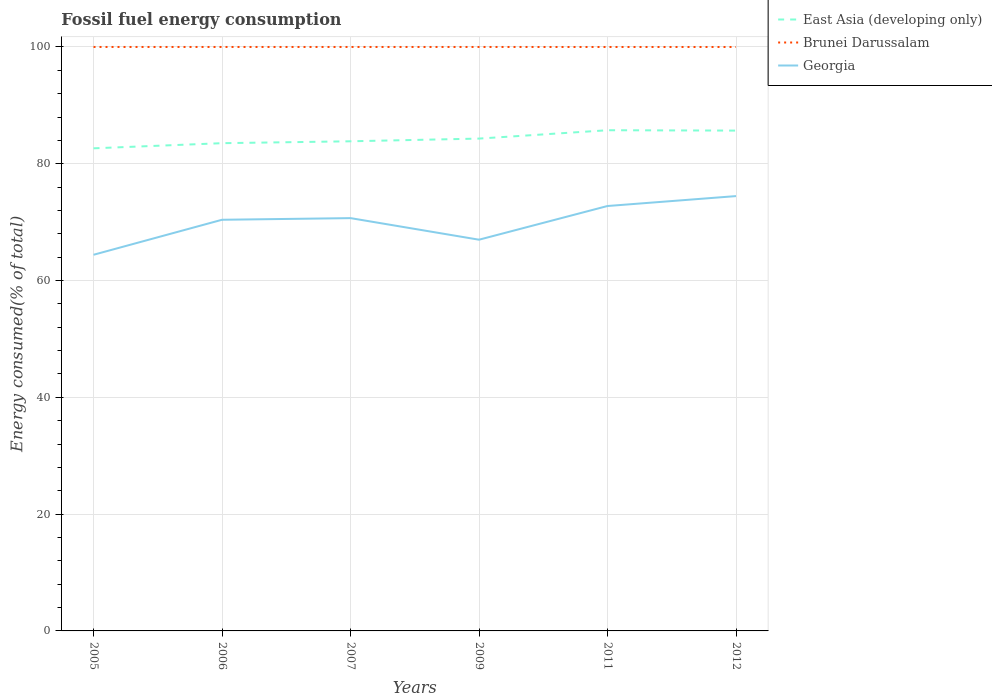Does the line corresponding to East Asia (developing only) intersect with the line corresponding to Brunei Darussalam?
Make the answer very short. No. Across all years, what is the maximum percentage of energy consumed in Georgia?
Offer a very short reply. 64.41. In which year was the percentage of energy consumed in Georgia maximum?
Make the answer very short. 2005. What is the total percentage of energy consumed in Georgia in the graph?
Your answer should be compact. -1.7. What is the difference between the highest and the second highest percentage of energy consumed in Georgia?
Provide a short and direct response. 10.05. What is the difference between the highest and the lowest percentage of energy consumed in Georgia?
Make the answer very short. 4. Are the values on the major ticks of Y-axis written in scientific E-notation?
Offer a terse response. No. Does the graph contain any zero values?
Provide a succinct answer. No. Does the graph contain grids?
Your answer should be compact. Yes. What is the title of the graph?
Give a very brief answer. Fossil fuel energy consumption. What is the label or title of the X-axis?
Your response must be concise. Years. What is the label or title of the Y-axis?
Your response must be concise. Energy consumed(% of total). What is the Energy consumed(% of total) in East Asia (developing only) in 2005?
Offer a terse response. 82.64. What is the Energy consumed(% of total) of Brunei Darussalam in 2005?
Your response must be concise. 100. What is the Energy consumed(% of total) in Georgia in 2005?
Keep it short and to the point. 64.41. What is the Energy consumed(% of total) of East Asia (developing only) in 2006?
Keep it short and to the point. 83.52. What is the Energy consumed(% of total) of Brunei Darussalam in 2006?
Provide a succinct answer. 100. What is the Energy consumed(% of total) in Georgia in 2006?
Your answer should be compact. 70.41. What is the Energy consumed(% of total) of East Asia (developing only) in 2007?
Keep it short and to the point. 83.85. What is the Energy consumed(% of total) of Georgia in 2007?
Provide a succinct answer. 70.69. What is the Energy consumed(% of total) in East Asia (developing only) in 2009?
Offer a very short reply. 84.31. What is the Energy consumed(% of total) in Brunei Darussalam in 2009?
Your response must be concise. 100. What is the Energy consumed(% of total) of Georgia in 2009?
Offer a very short reply. 66.99. What is the Energy consumed(% of total) of East Asia (developing only) in 2011?
Provide a succinct answer. 85.74. What is the Energy consumed(% of total) in Brunei Darussalam in 2011?
Provide a succinct answer. 100. What is the Energy consumed(% of total) of Georgia in 2011?
Ensure brevity in your answer.  72.77. What is the Energy consumed(% of total) of East Asia (developing only) in 2012?
Provide a short and direct response. 85.68. What is the Energy consumed(% of total) in Brunei Darussalam in 2012?
Offer a very short reply. 100. What is the Energy consumed(% of total) of Georgia in 2012?
Ensure brevity in your answer.  74.46. Across all years, what is the maximum Energy consumed(% of total) in East Asia (developing only)?
Your answer should be very brief. 85.74. Across all years, what is the maximum Energy consumed(% of total) in Brunei Darussalam?
Offer a very short reply. 100. Across all years, what is the maximum Energy consumed(% of total) of Georgia?
Provide a short and direct response. 74.46. Across all years, what is the minimum Energy consumed(% of total) of East Asia (developing only)?
Provide a succinct answer. 82.64. Across all years, what is the minimum Energy consumed(% of total) in Brunei Darussalam?
Your answer should be compact. 100. Across all years, what is the minimum Energy consumed(% of total) in Georgia?
Offer a terse response. 64.41. What is the total Energy consumed(% of total) of East Asia (developing only) in the graph?
Keep it short and to the point. 505.75. What is the total Energy consumed(% of total) of Brunei Darussalam in the graph?
Provide a succinct answer. 599.99. What is the total Energy consumed(% of total) of Georgia in the graph?
Provide a succinct answer. 419.73. What is the difference between the Energy consumed(% of total) of East Asia (developing only) in 2005 and that in 2006?
Give a very brief answer. -0.88. What is the difference between the Energy consumed(% of total) in Brunei Darussalam in 2005 and that in 2006?
Your answer should be very brief. 0. What is the difference between the Energy consumed(% of total) in Georgia in 2005 and that in 2006?
Offer a very short reply. -6. What is the difference between the Energy consumed(% of total) of East Asia (developing only) in 2005 and that in 2007?
Give a very brief answer. -1.2. What is the difference between the Energy consumed(% of total) in Brunei Darussalam in 2005 and that in 2007?
Ensure brevity in your answer.  0. What is the difference between the Energy consumed(% of total) of Georgia in 2005 and that in 2007?
Your answer should be very brief. -6.28. What is the difference between the Energy consumed(% of total) in East Asia (developing only) in 2005 and that in 2009?
Give a very brief answer. -1.67. What is the difference between the Energy consumed(% of total) of Georgia in 2005 and that in 2009?
Give a very brief answer. -2.58. What is the difference between the Energy consumed(% of total) in East Asia (developing only) in 2005 and that in 2011?
Provide a succinct answer. -3.1. What is the difference between the Energy consumed(% of total) of Brunei Darussalam in 2005 and that in 2011?
Keep it short and to the point. 0. What is the difference between the Energy consumed(% of total) of Georgia in 2005 and that in 2011?
Offer a terse response. -8.35. What is the difference between the Energy consumed(% of total) in East Asia (developing only) in 2005 and that in 2012?
Your answer should be very brief. -3.04. What is the difference between the Energy consumed(% of total) of Brunei Darussalam in 2005 and that in 2012?
Your answer should be compact. 0. What is the difference between the Energy consumed(% of total) in Georgia in 2005 and that in 2012?
Your answer should be very brief. -10.05. What is the difference between the Energy consumed(% of total) in East Asia (developing only) in 2006 and that in 2007?
Offer a very short reply. -0.32. What is the difference between the Energy consumed(% of total) of Georgia in 2006 and that in 2007?
Offer a very short reply. -0.28. What is the difference between the Energy consumed(% of total) in East Asia (developing only) in 2006 and that in 2009?
Offer a very short reply. -0.79. What is the difference between the Energy consumed(% of total) in Brunei Darussalam in 2006 and that in 2009?
Make the answer very short. 0. What is the difference between the Energy consumed(% of total) in Georgia in 2006 and that in 2009?
Offer a very short reply. 3.42. What is the difference between the Energy consumed(% of total) of East Asia (developing only) in 2006 and that in 2011?
Ensure brevity in your answer.  -2.22. What is the difference between the Energy consumed(% of total) of Brunei Darussalam in 2006 and that in 2011?
Give a very brief answer. 0. What is the difference between the Energy consumed(% of total) of Georgia in 2006 and that in 2011?
Keep it short and to the point. -2.36. What is the difference between the Energy consumed(% of total) in East Asia (developing only) in 2006 and that in 2012?
Offer a terse response. -2.16. What is the difference between the Energy consumed(% of total) of Brunei Darussalam in 2006 and that in 2012?
Provide a succinct answer. 0. What is the difference between the Energy consumed(% of total) in Georgia in 2006 and that in 2012?
Keep it short and to the point. -4.05. What is the difference between the Energy consumed(% of total) in East Asia (developing only) in 2007 and that in 2009?
Offer a very short reply. -0.46. What is the difference between the Energy consumed(% of total) of Brunei Darussalam in 2007 and that in 2009?
Your response must be concise. 0. What is the difference between the Energy consumed(% of total) in Georgia in 2007 and that in 2009?
Offer a very short reply. 3.7. What is the difference between the Energy consumed(% of total) of East Asia (developing only) in 2007 and that in 2011?
Offer a terse response. -1.89. What is the difference between the Energy consumed(% of total) in Brunei Darussalam in 2007 and that in 2011?
Provide a succinct answer. 0. What is the difference between the Energy consumed(% of total) of Georgia in 2007 and that in 2011?
Your response must be concise. -2.07. What is the difference between the Energy consumed(% of total) of East Asia (developing only) in 2007 and that in 2012?
Give a very brief answer. -1.83. What is the difference between the Energy consumed(% of total) in Brunei Darussalam in 2007 and that in 2012?
Make the answer very short. 0. What is the difference between the Energy consumed(% of total) in Georgia in 2007 and that in 2012?
Offer a terse response. -3.77. What is the difference between the Energy consumed(% of total) in East Asia (developing only) in 2009 and that in 2011?
Offer a very short reply. -1.43. What is the difference between the Energy consumed(% of total) in Brunei Darussalam in 2009 and that in 2011?
Keep it short and to the point. 0. What is the difference between the Energy consumed(% of total) in Georgia in 2009 and that in 2011?
Your answer should be very brief. -5.77. What is the difference between the Energy consumed(% of total) of East Asia (developing only) in 2009 and that in 2012?
Keep it short and to the point. -1.37. What is the difference between the Energy consumed(% of total) in Brunei Darussalam in 2009 and that in 2012?
Your answer should be very brief. 0. What is the difference between the Energy consumed(% of total) in Georgia in 2009 and that in 2012?
Your answer should be very brief. -7.47. What is the difference between the Energy consumed(% of total) in East Asia (developing only) in 2011 and that in 2012?
Keep it short and to the point. 0.06. What is the difference between the Energy consumed(% of total) of Brunei Darussalam in 2011 and that in 2012?
Your response must be concise. 0. What is the difference between the Energy consumed(% of total) of Georgia in 2011 and that in 2012?
Your answer should be very brief. -1.7. What is the difference between the Energy consumed(% of total) of East Asia (developing only) in 2005 and the Energy consumed(% of total) of Brunei Darussalam in 2006?
Keep it short and to the point. -17.36. What is the difference between the Energy consumed(% of total) of East Asia (developing only) in 2005 and the Energy consumed(% of total) of Georgia in 2006?
Your answer should be compact. 12.24. What is the difference between the Energy consumed(% of total) in Brunei Darussalam in 2005 and the Energy consumed(% of total) in Georgia in 2006?
Provide a short and direct response. 29.59. What is the difference between the Energy consumed(% of total) of East Asia (developing only) in 2005 and the Energy consumed(% of total) of Brunei Darussalam in 2007?
Ensure brevity in your answer.  -17.36. What is the difference between the Energy consumed(% of total) in East Asia (developing only) in 2005 and the Energy consumed(% of total) in Georgia in 2007?
Your answer should be compact. 11.95. What is the difference between the Energy consumed(% of total) in Brunei Darussalam in 2005 and the Energy consumed(% of total) in Georgia in 2007?
Your answer should be compact. 29.31. What is the difference between the Energy consumed(% of total) of East Asia (developing only) in 2005 and the Energy consumed(% of total) of Brunei Darussalam in 2009?
Offer a very short reply. -17.36. What is the difference between the Energy consumed(% of total) of East Asia (developing only) in 2005 and the Energy consumed(% of total) of Georgia in 2009?
Give a very brief answer. 15.65. What is the difference between the Energy consumed(% of total) in Brunei Darussalam in 2005 and the Energy consumed(% of total) in Georgia in 2009?
Provide a short and direct response. 33.01. What is the difference between the Energy consumed(% of total) of East Asia (developing only) in 2005 and the Energy consumed(% of total) of Brunei Darussalam in 2011?
Your answer should be very brief. -17.35. What is the difference between the Energy consumed(% of total) of East Asia (developing only) in 2005 and the Energy consumed(% of total) of Georgia in 2011?
Your response must be concise. 9.88. What is the difference between the Energy consumed(% of total) in Brunei Darussalam in 2005 and the Energy consumed(% of total) in Georgia in 2011?
Your response must be concise. 27.23. What is the difference between the Energy consumed(% of total) of East Asia (developing only) in 2005 and the Energy consumed(% of total) of Brunei Darussalam in 2012?
Provide a succinct answer. -17.35. What is the difference between the Energy consumed(% of total) of East Asia (developing only) in 2005 and the Energy consumed(% of total) of Georgia in 2012?
Keep it short and to the point. 8.18. What is the difference between the Energy consumed(% of total) in Brunei Darussalam in 2005 and the Energy consumed(% of total) in Georgia in 2012?
Offer a terse response. 25.54. What is the difference between the Energy consumed(% of total) of East Asia (developing only) in 2006 and the Energy consumed(% of total) of Brunei Darussalam in 2007?
Provide a succinct answer. -16.48. What is the difference between the Energy consumed(% of total) of East Asia (developing only) in 2006 and the Energy consumed(% of total) of Georgia in 2007?
Give a very brief answer. 12.83. What is the difference between the Energy consumed(% of total) of Brunei Darussalam in 2006 and the Energy consumed(% of total) of Georgia in 2007?
Offer a terse response. 29.31. What is the difference between the Energy consumed(% of total) in East Asia (developing only) in 2006 and the Energy consumed(% of total) in Brunei Darussalam in 2009?
Your answer should be compact. -16.48. What is the difference between the Energy consumed(% of total) in East Asia (developing only) in 2006 and the Energy consumed(% of total) in Georgia in 2009?
Your response must be concise. 16.53. What is the difference between the Energy consumed(% of total) in Brunei Darussalam in 2006 and the Energy consumed(% of total) in Georgia in 2009?
Offer a terse response. 33.01. What is the difference between the Energy consumed(% of total) in East Asia (developing only) in 2006 and the Energy consumed(% of total) in Brunei Darussalam in 2011?
Make the answer very short. -16.47. What is the difference between the Energy consumed(% of total) of East Asia (developing only) in 2006 and the Energy consumed(% of total) of Georgia in 2011?
Your answer should be compact. 10.76. What is the difference between the Energy consumed(% of total) of Brunei Darussalam in 2006 and the Energy consumed(% of total) of Georgia in 2011?
Ensure brevity in your answer.  27.23. What is the difference between the Energy consumed(% of total) of East Asia (developing only) in 2006 and the Energy consumed(% of total) of Brunei Darussalam in 2012?
Your answer should be compact. -16.47. What is the difference between the Energy consumed(% of total) in East Asia (developing only) in 2006 and the Energy consumed(% of total) in Georgia in 2012?
Ensure brevity in your answer.  9.06. What is the difference between the Energy consumed(% of total) of Brunei Darussalam in 2006 and the Energy consumed(% of total) of Georgia in 2012?
Keep it short and to the point. 25.54. What is the difference between the Energy consumed(% of total) in East Asia (developing only) in 2007 and the Energy consumed(% of total) in Brunei Darussalam in 2009?
Offer a very short reply. -16.15. What is the difference between the Energy consumed(% of total) of East Asia (developing only) in 2007 and the Energy consumed(% of total) of Georgia in 2009?
Offer a terse response. 16.85. What is the difference between the Energy consumed(% of total) in Brunei Darussalam in 2007 and the Energy consumed(% of total) in Georgia in 2009?
Offer a terse response. 33.01. What is the difference between the Energy consumed(% of total) of East Asia (developing only) in 2007 and the Energy consumed(% of total) of Brunei Darussalam in 2011?
Make the answer very short. -16.15. What is the difference between the Energy consumed(% of total) of East Asia (developing only) in 2007 and the Energy consumed(% of total) of Georgia in 2011?
Make the answer very short. 11.08. What is the difference between the Energy consumed(% of total) in Brunei Darussalam in 2007 and the Energy consumed(% of total) in Georgia in 2011?
Keep it short and to the point. 27.23. What is the difference between the Energy consumed(% of total) in East Asia (developing only) in 2007 and the Energy consumed(% of total) in Brunei Darussalam in 2012?
Your answer should be compact. -16.15. What is the difference between the Energy consumed(% of total) in East Asia (developing only) in 2007 and the Energy consumed(% of total) in Georgia in 2012?
Make the answer very short. 9.38. What is the difference between the Energy consumed(% of total) in Brunei Darussalam in 2007 and the Energy consumed(% of total) in Georgia in 2012?
Your response must be concise. 25.54. What is the difference between the Energy consumed(% of total) in East Asia (developing only) in 2009 and the Energy consumed(% of total) in Brunei Darussalam in 2011?
Make the answer very short. -15.69. What is the difference between the Energy consumed(% of total) of East Asia (developing only) in 2009 and the Energy consumed(% of total) of Georgia in 2011?
Provide a succinct answer. 11.55. What is the difference between the Energy consumed(% of total) of Brunei Darussalam in 2009 and the Energy consumed(% of total) of Georgia in 2011?
Your answer should be very brief. 27.23. What is the difference between the Energy consumed(% of total) of East Asia (developing only) in 2009 and the Energy consumed(% of total) of Brunei Darussalam in 2012?
Offer a very short reply. -15.69. What is the difference between the Energy consumed(% of total) in East Asia (developing only) in 2009 and the Energy consumed(% of total) in Georgia in 2012?
Keep it short and to the point. 9.85. What is the difference between the Energy consumed(% of total) in Brunei Darussalam in 2009 and the Energy consumed(% of total) in Georgia in 2012?
Offer a very short reply. 25.54. What is the difference between the Energy consumed(% of total) of East Asia (developing only) in 2011 and the Energy consumed(% of total) of Brunei Darussalam in 2012?
Make the answer very short. -14.25. What is the difference between the Energy consumed(% of total) in East Asia (developing only) in 2011 and the Energy consumed(% of total) in Georgia in 2012?
Your answer should be very brief. 11.28. What is the difference between the Energy consumed(% of total) in Brunei Darussalam in 2011 and the Energy consumed(% of total) in Georgia in 2012?
Keep it short and to the point. 25.53. What is the average Energy consumed(% of total) of East Asia (developing only) per year?
Give a very brief answer. 84.29. What is the average Energy consumed(% of total) in Brunei Darussalam per year?
Provide a short and direct response. 100. What is the average Energy consumed(% of total) of Georgia per year?
Ensure brevity in your answer.  69.96. In the year 2005, what is the difference between the Energy consumed(% of total) in East Asia (developing only) and Energy consumed(% of total) in Brunei Darussalam?
Your answer should be compact. -17.36. In the year 2005, what is the difference between the Energy consumed(% of total) of East Asia (developing only) and Energy consumed(% of total) of Georgia?
Your answer should be compact. 18.23. In the year 2005, what is the difference between the Energy consumed(% of total) of Brunei Darussalam and Energy consumed(% of total) of Georgia?
Provide a short and direct response. 35.59. In the year 2006, what is the difference between the Energy consumed(% of total) in East Asia (developing only) and Energy consumed(% of total) in Brunei Darussalam?
Provide a succinct answer. -16.48. In the year 2006, what is the difference between the Energy consumed(% of total) of East Asia (developing only) and Energy consumed(% of total) of Georgia?
Your answer should be compact. 13.11. In the year 2006, what is the difference between the Energy consumed(% of total) in Brunei Darussalam and Energy consumed(% of total) in Georgia?
Provide a succinct answer. 29.59. In the year 2007, what is the difference between the Energy consumed(% of total) in East Asia (developing only) and Energy consumed(% of total) in Brunei Darussalam?
Give a very brief answer. -16.15. In the year 2007, what is the difference between the Energy consumed(% of total) of East Asia (developing only) and Energy consumed(% of total) of Georgia?
Your answer should be compact. 13.16. In the year 2007, what is the difference between the Energy consumed(% of total) in Brunei Darussalam and Energy consumed(% of total) in Georgia?
Make the answer very short. 29.31. In the year 2009, what is the difference between the Energy consumed(% of total) of East Asia (developing only) and Energy consumed(% of total) of Brunei Darussalam?
Provide a succinct answer. -15.69. In the year 2009, what is the difference between the Energy consumed(% of total) in East Asia (developing only) and Energy consumed(% of total) in Georgia?
Your response must be concise. 17.32. In the year 2009, what is the difference between the Energy consumed(% of total) in Brunei Darussalam and Energy consumed(% of total) in Georgia?
Your response must be concise. 33.01. In the year 2011, what is the difference between the Energy consumed(% of total) in East Asia (developing only) and Energy consumed(% of total) in Brunei Darussalam?
Give a very brief answer. -14.25. In the year 2011, what is the difference between the Energy consumed(% of total) of East Asia (developing only) and Energy consumed(% of total) of Georgia?
Offer a terse response. 12.98. In the year 2011, what is the difference between the Energy consumed(% of total) in Brunei Darussalam and Energy consumed(% of total) in Georgia?
Ensure brevity in your answer.  27.23. In the year 2012, what is the difference between the Energy consumed(% of total) in East Asia (developing only) and Energy consumed(% of total) in Brunei Darussalam?
Ensure brevity in your answer.  -14.32. In the year 2012, what is the difference between the Energy consumed(% of total) in East Asia (developing only) and Energy consumed(% of total) in Georgia?
Your answer should be very brief. 11.22. In the year 2012, what is the difference between the Energy consumed(% of total) of Brunei Darussalam and Energy consumed(% of total) of Georgia?
Give a very brief answer. 25.53. What is the ratio of the Energy consumed(% of total) of Georgia in 2005 to that in 2006?
Ensure brevity in your answer.  0.91. What is the ratio of the Energy consumed(% of total) in East Asia (developing only) in 2005 to that in 2007?
Offer a very short reply. 0.99. What is the ratio of the Energy consumed(% of total) in Georgia in 2005 to that in 2007?
Provide a succinct answer. 0.91. What is the ratio of the Energy consumed(% of total) of East Asia (developing only) in 2005 to that in 2009?
Ensure brevity in your answer.  0.98. What is the ratio of the Energy consumed(% of total) in Georgia in 2005 to that in 2009?
Provide a short and direct response. 0.96. What is the ratio of the Energy consumed(% of total) of East Asia (developing only) in 2005 to that in 2011?
Give a very brief answer. 0.96. What is the ratio of the Energy consumed(% of total) of Georgia in 2005 to that in 2011?
Your answer should be compact. 0.89. What is the ratio of the Energy consumed(% of total) in East Asia (developing only) in 2005 to that in 2012?
Offer a very short reply. 0.96. What is the ratio of the Energy consumed(% of total) of Brunei Darussalam in 2005 to that in 2012?
Keep it short and to the point. 1. What is the ratio of the Energy consumed(% of total) in Georgia in 2005 to that in 2012?
Offer a very short reply. 0.86. What is the ratio of the Energy consumed(% of total) in East Asia (developing only) in 2006 to that in 2007?
Ensure brevity in your answer.  1. What is the ratio of the Energy consumed(% of total) in Brunei Darussalam in 2006 to that in 2007?
Your response must be concise. 1. What is the ratio of the Energy consumed(% of total) of East Asia (developing only) in 2006 to that in 2009?
Your response must be concise. 0.99. What is the ratio of the Energy consumed(% of total) of Brunei Darussalam in 2006 to that in 2009?
Ensure brevity in your answer.  1. What is the ratio of the Energy consumed(% of total) of Georgia in 2006 to that in 2009?
Your answer should be compact. 1.05. What is the ratio of the Energy consumed(% of total) in East Asia (developing only) in 2006 to that in 2011?
Provide a succinct answer. 0.97. What is the ratio of the Energy consumed(% of total) of Brunei Darussalam in 2006 to that in 2011?
Offer a terse response. 1. What is the ratio of the Energy consumed(% of total) of Georgia in 2006 to that in 2011?
Keep it short and to the point. 0.97. What is the ratio of the Energy consumed(% of total) in East Asia (developing only) in 2006 to that in 2012?
Ensure brevity in your answer.  0.97. What is the ratio of the Energy consumed(% of total) in Georgia in 2006 to that in 2012?
Ensure brevity in your answer.  0.95. What is the ratio of the Energy consumed(% of total) in Brunei Darussalam in 2007 to that in 2009?
Your response must be concise. 1. What is the ratio of the Energy consumed(% of total) of Georgia in 2007 to that in 2009?
Offer a terse response. 1.06. What is the ratio of the Energy consumed(% of total) in East Asia (developing only) in 2007 to that in 2011?
Offer a very short reply. 0.98. What is the ratio of the Energy consumed(% of total) of Georgia in 2007 to that in 2011?
Keep it short and to the point. 0.97. What is the ratio of the Energy consumed(% of total) of East Asia (developing only) in 2007 to that in 2012?
Keep it short and to the point. 0.98. What is the ratio of the Energy consumed(% of total) in Brunei Darussalam in 2007 to that in 2012?
Ensure brevity in your answer.  1. What is the ratio of the Energy consumed(% of total) of Georgia in 2007 to that in 2012?
Offer a terse response. 0.95. What is the ratio of the Energy consumed(% of total) of East Asia (developing only) in 2009 to that in 2011?
Offer a terse response. 0.98. What is the ratio of the Energy consumed(% of total) in Brunei Darussalam in 2009 to that in 2011?
Make the answer very short. 1. What is the ratio of the Energy consumed(% of total) of Georgia in 2009 to that in 2011?
Your answer should be very brief. 0.92. What is the ratio of the Energy consumed(% of total) of Georgia in 2009 to that in 2012?
Your response must be concise. 0.9. What is the ratio of the Energy consumed(% of total) of East Asia (developing only) in 2011 to that in 2012?
Provide a short and direct response. 1. What is the ratio of the Energy consumed(% of total) of Brunei Darussalam in 2011 to that in 2012?
Your response must be concise. 1. What is the ratio of the Energy consumed(% of total) in Georgia in 2011 to that in 2012?
Provide a short and direct response. 0.98. What is the difference between the highest and the second highest Energy consumed(% of total) in East Asia (developing only)?
Your answer should be compact. 0.06. What is the difference between the highest and the second highest Energy consumed(% of total) of Brunei Darussalam?
Provide a short and direct response. 0. What is the difference between the highest and the second highest Energy consumed(% of total) of Georgia?
Provide a short and direct response. 1.7. What is the difference between the highest and the lowest Energy consumed(% of total) of East Asia (developing only)?
Keep it short and to the point. 3.1. What is the difference between the highest and the lowest Energy consumed(% of total) of Brunei Darussalam?
Offer a terse response. 0. What is the difference between the highest and the lowest Energy consumed(% of total) of Georgia?
Your response must be concise. 10.05. 